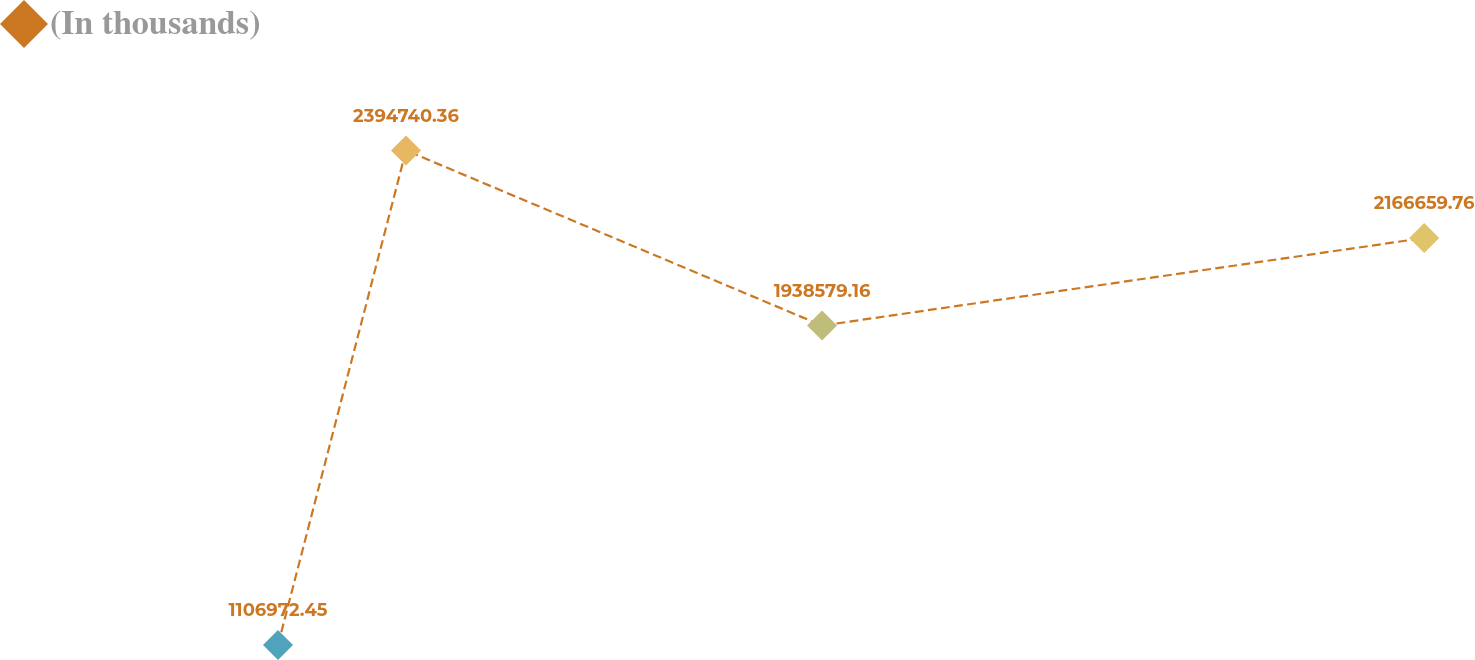<chart> <loc_0><loc_0><loc_500><loc_500><line_chart><ecel><fcel>(In thousands)<nl><fcel>1652.59<fcel>1.10697e+06<nl><fcel>1726.29<fcel>2.39474e+06<nl><fcel>1965.84<fcel>1.93858e+06<nl><fcel>2312.51<fcel>2.16666e+06<nl><fcel>2389.57<fcel>3.38778e+06<nl></chart> 